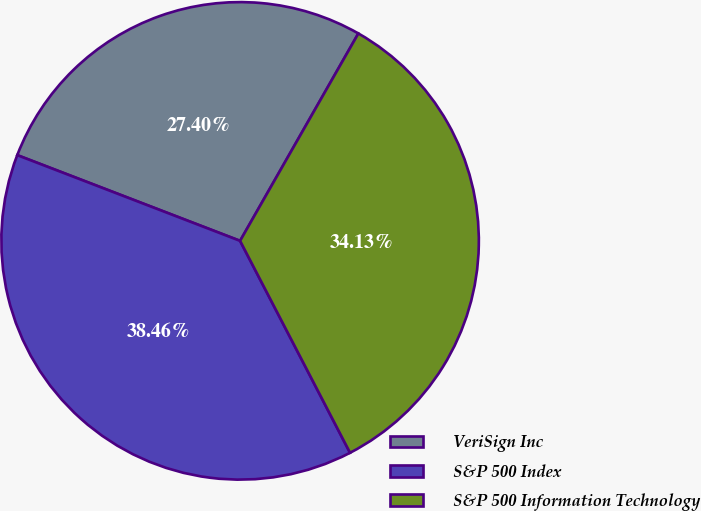Convert chart to OTSL. <chart><loc_0><loc_0><loc_500><loc_500><pie_chart><fcel>VeriSign Inc<fcel>S&P 500 Index<fcel>S&P 500 Information Technology<nl><fcel>27.4%<fcel>38.46%<fcel>34.13%<nl></chart> 